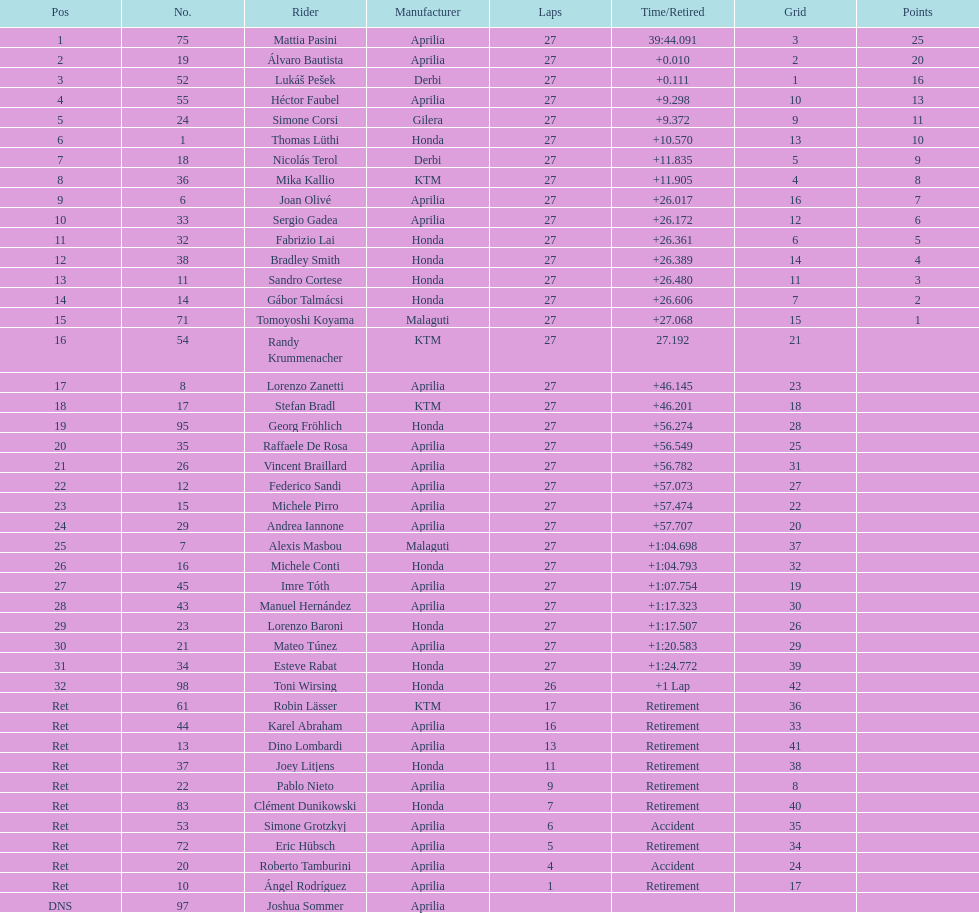Among individuals with points, who possesses the lowest amount? Tomoyoshi Koyama. 